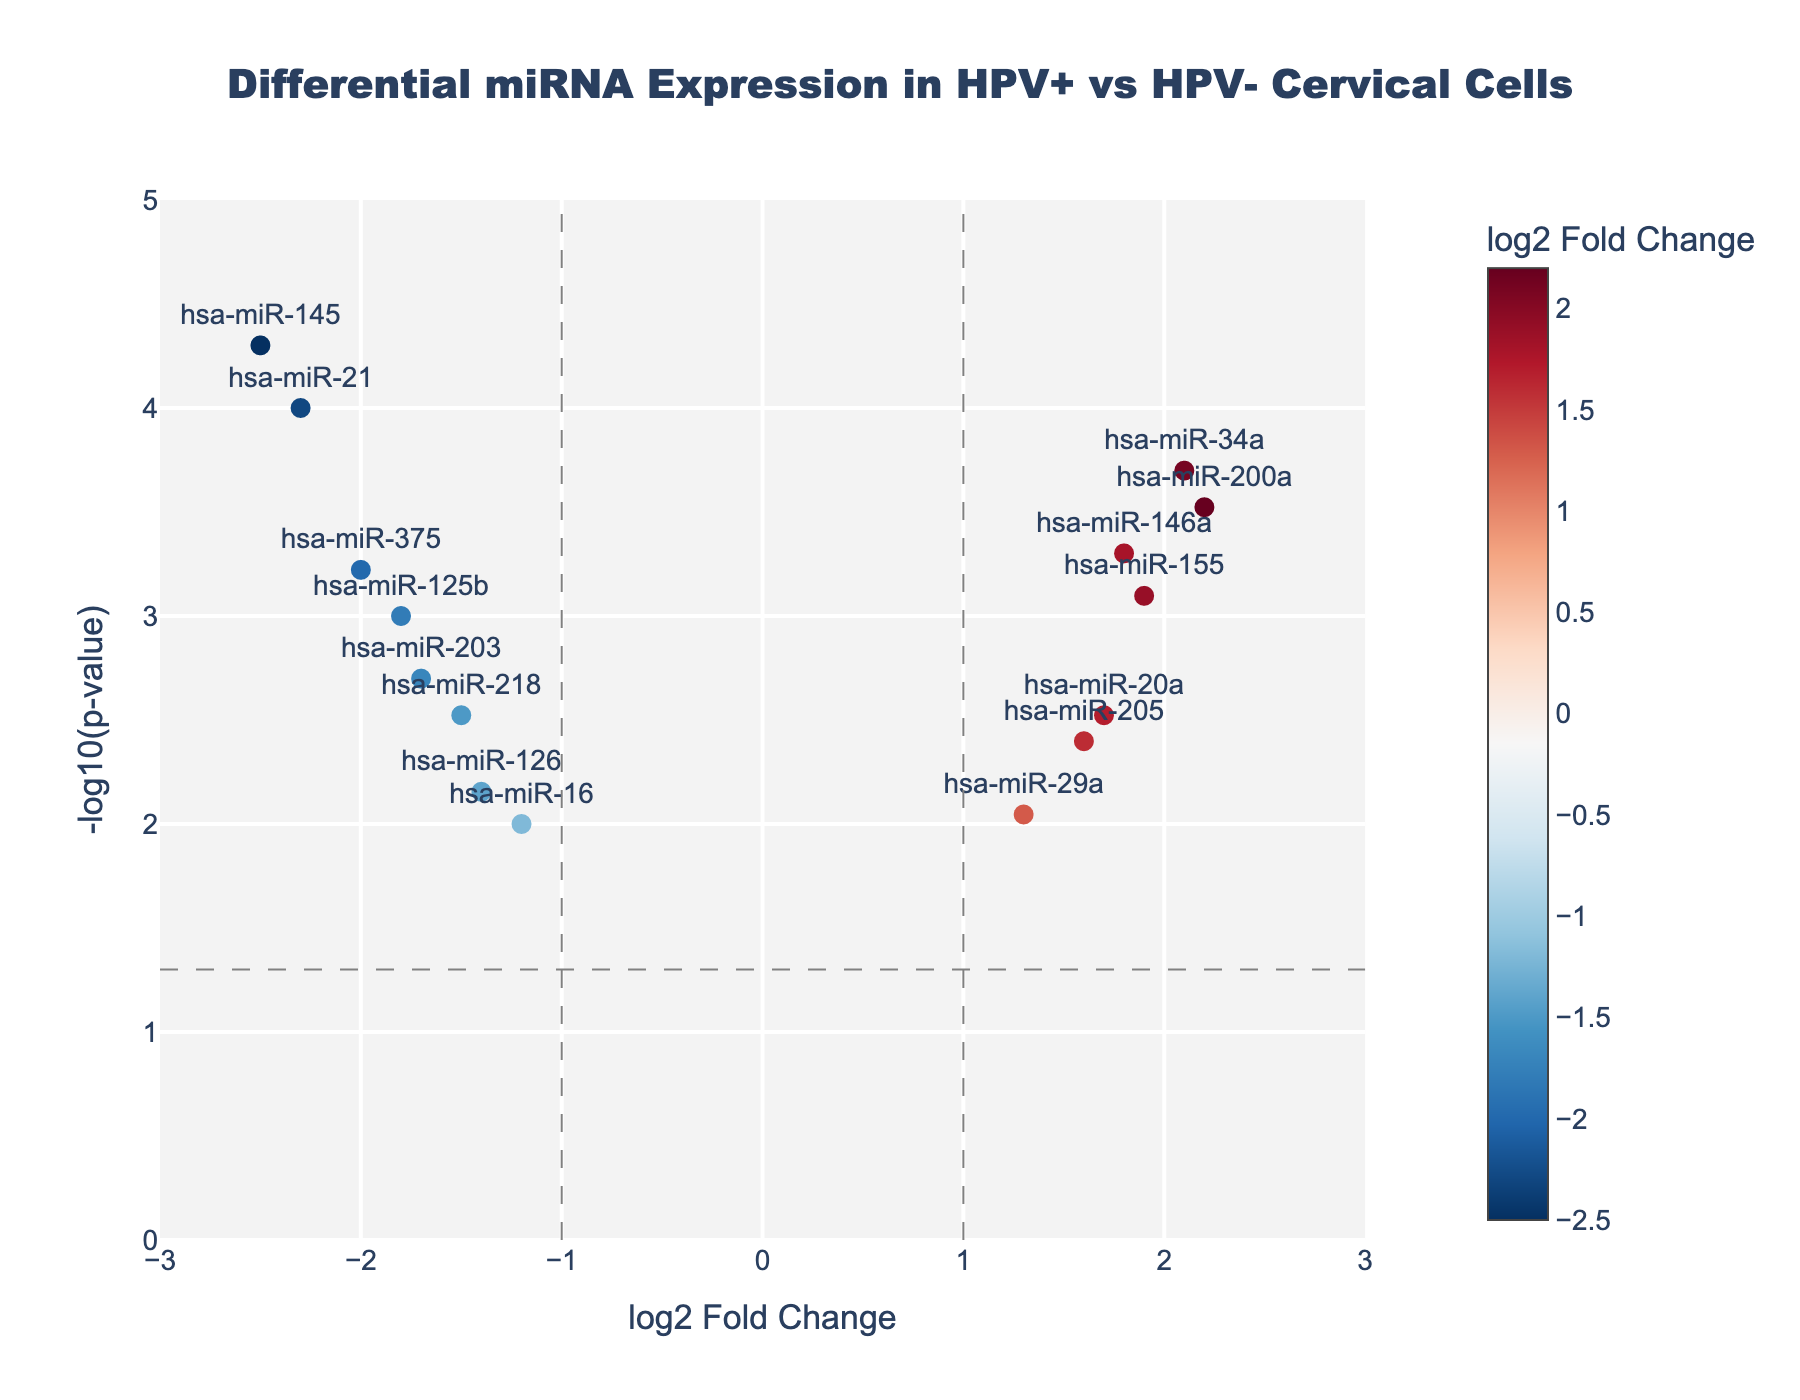What is the main title of the plot? The main title of the plot is usually displayed prominently at the top of the figure.
Answer: Differential miRNA Expression in HPV+ vs HPV- Cervical Cells How many miRNAs have a log2FoldChange greater than 1? Looking at the x-axis values (log2FoldChange), count the number of miRNAs that are positioned to the right of the vertical line at log2FoldChange = 1.
Answer: 5 Which miRNA has the smallest p-value? Identify the miRNA with the highest -log10(p-value) value on the y-axis, as a smaller p-value corresponds to a larger -log10(p-value).
Answer: hsa-miR-145 What is the range of -log10(p-value) in the plot? Observe the y-axis labels to determine the minimum and maximum values represented on the axis.
Answer: 0 to 5 How many miRNAs are downregulated in HPV-positive cells? Count the number of data points with negative log2FoldChange values (on the left side of the vertical line at log2FoldChange = 0).
Answer: 7 Which miRNAs have a log2FoldChange between -1 and 1? Identify the data points that lie within the vertical lines at log2FoldChange = -1 and log2FoldChange = 1 on the x-axis.
Answer: hsa-miR-16, hsa-miR-126, hsa-miR-29a How many miRNAs are significantly differentially expressed at a p-value threshold of 0.05? Count the number of data points above the horizontal line at -log10(0.05).
Answer: 11 Which miRNA has the highest log2FoldChange? Identify the miRNA with the rightmost position on the x-axis, indicating the highest positive log2FoldChange value.
Answer: hsa-miR-200a What is the color scale used for the markers, and what does it represent? The color bar indicates that colors vary based on log2FoldChange, with a specific color range representing different log2FoldChange values.
Answer: Color gradient represents log2FoldChange Which miRNA has a log2FoldChange of approximately -2.0 and what is its p-value? Locate the data point around log2FoldChange = -2.0 and read the hover text for its specific p-value.
Answer: hsa-miR-375, p-value ≈ 0.0006 